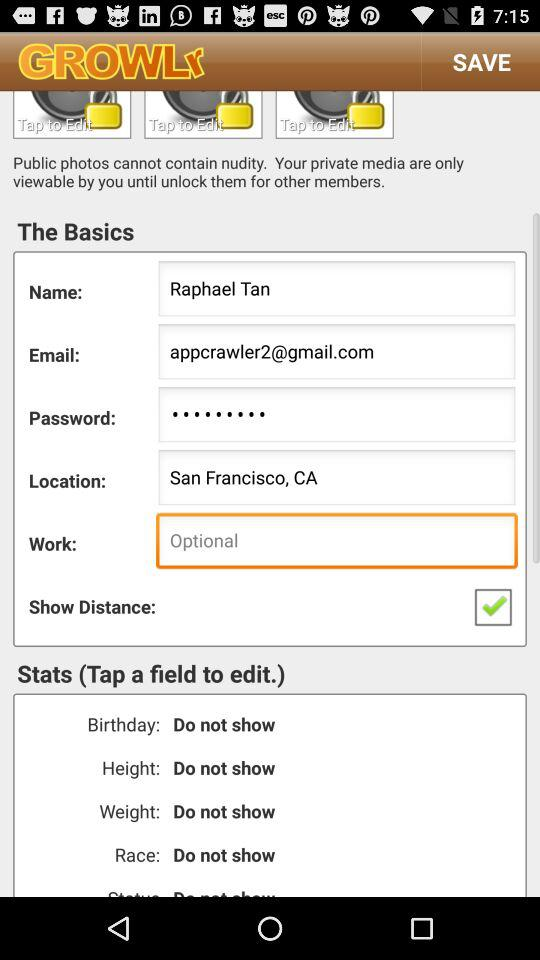What is the name of the user? The name of the user is Raphael Tan. 